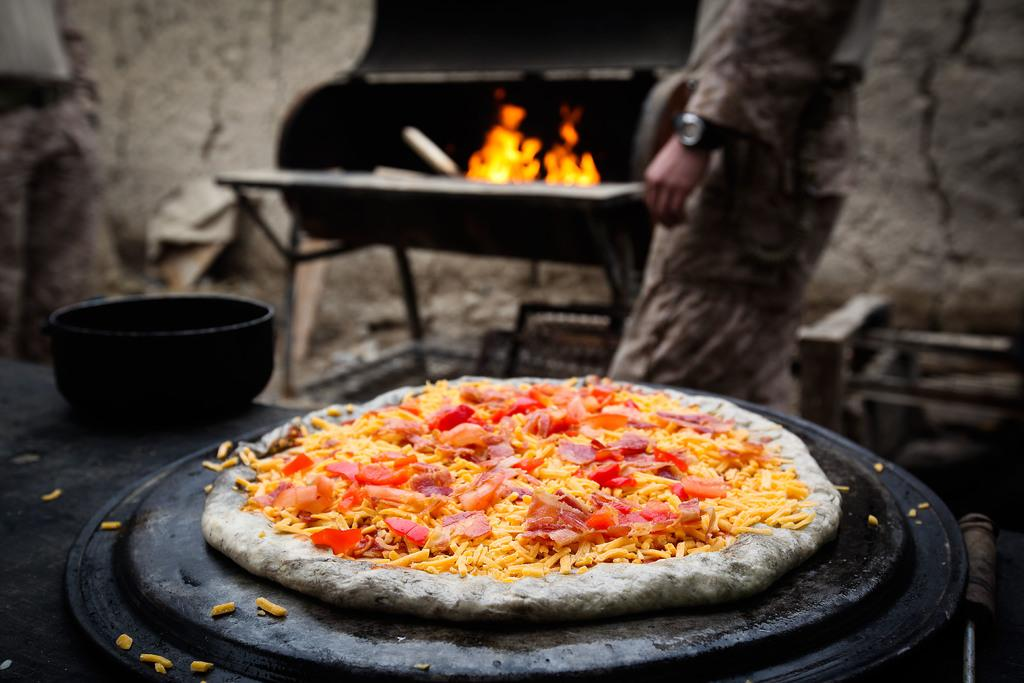What type of food is visible in the image? There is a pizza in the image. Can you describe the background of the image? There is a person, a bowl, and fire in the background of the image. What type of umbrella is being used by the volleyball coach in the image? There is no volleyball coach or umbrella present in the image. 